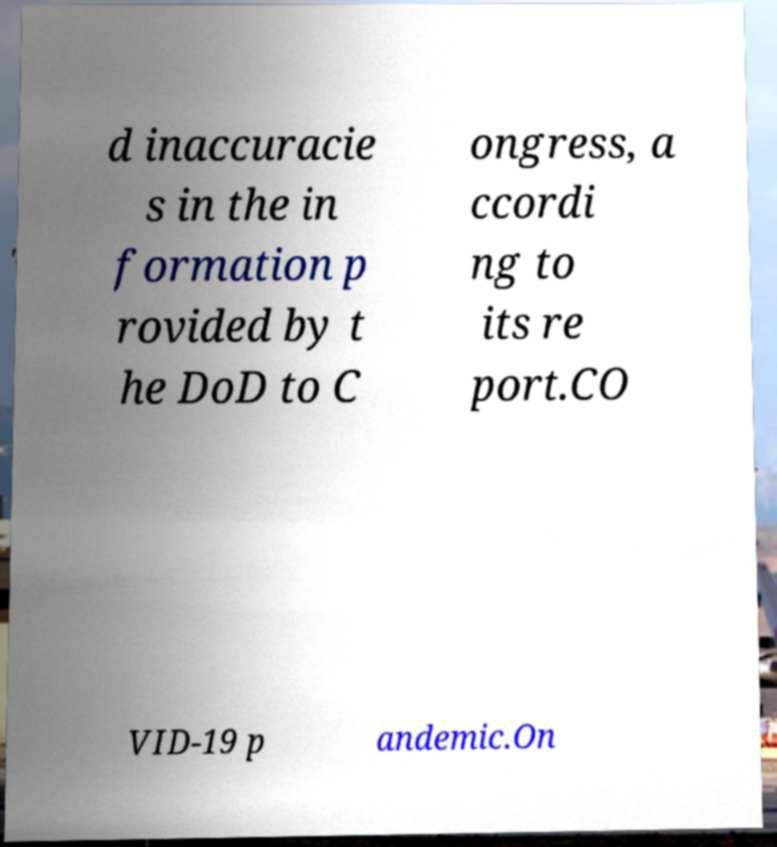Can you accurately transcribe the text from the provided image for me? d inaccuracie s in the in formation p rovided by t he DoD to C ongress, a ccordi ng to its re port.CO VID-19 p andemic.On 